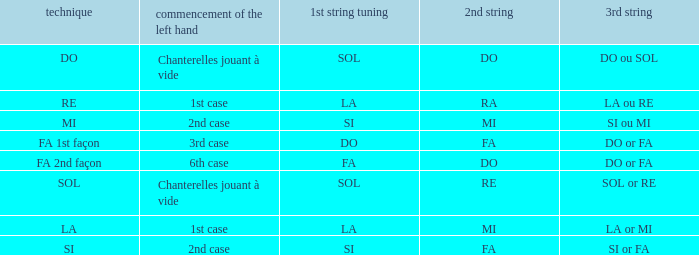What is the mode of the Depart de la main gauche of 1st case and a la or mi 3rd string? LA. 